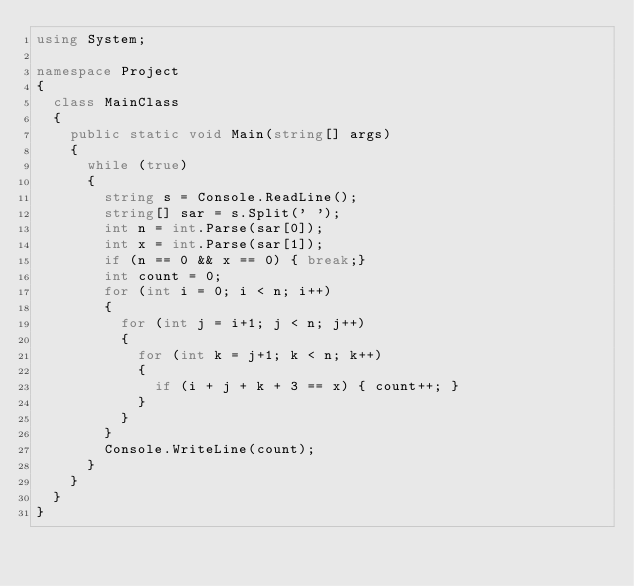Convert code to text. <code><loc_0><loc_0><loc_500><loc_500><_C#_>using System;

namespace Project
{
	class MainClass
	{
		public static void Main(string[] args)
		{
			while (true)
			{
				string s = Console.ReadLine();
				string[] sar = s.Split(' ');
				int n = int.Parse(sar[0]);
				int x = int.Parse(sar[1]);
				if (n == 0 && x == 0) { break;}
				int count = 0;
				for (int i = 0; i < n; i++)
				{
					for (int j = i+1; j < n; j++)
					{
						for (int k = j+1; k < n; k++)
						{
							if (i + j + k + 3 == x) { count++; }
						}
					}
				}
				Console.WriteLine(count);
			}
		}
	}
}</code> 